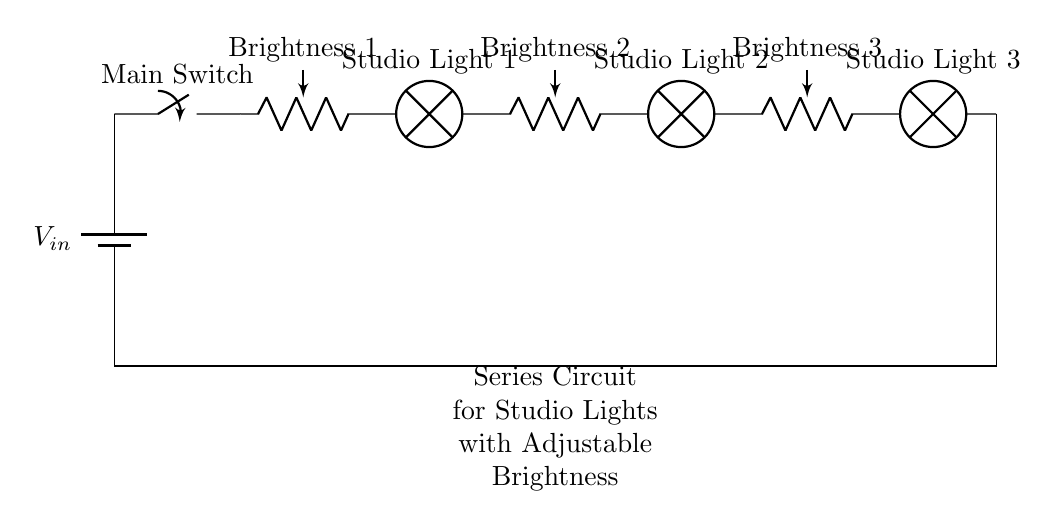What is the input voltage of this circuit? The input voltage is indicated as \( V_{in} \) at the power source. This is where the circuit receives its electrical energy.
Answer: \( V_{in} \) How many studio lights are in this circuit? The circuit diagram shows three lamps labeled as Studio Light 1, Studio Light 2, and Studio Light 3, which represent the studio lights.
Answer: 3 What components are used to adjust brightness? The components used for adjusting brightness are the potentiometers positioned before each studio light in the circuit.
Answer: Potentiometers What is the connection type of the circuit? The connection type is a series circuit, as all the components are connected sequentially, allowing the same current to flow through each.
Answer: Series If one studio light goes out, what happens to the others? In a series circuit, if one component (like a studio light) fails, it breaks the circuit, causing all other components to stop working as well.
Answer: All go out What is the function of the main switch in this circuit? The main switch controls the overall flow of current in the circuit, allowing it to be turned on or off, hence controlling all connected components.
Answer: Control current Which studio light is positioned last in the circuit? Studio Light 3 is the last component in the circuit, connected after the second brightness potentiometer.
Answer: Studio Light 3 